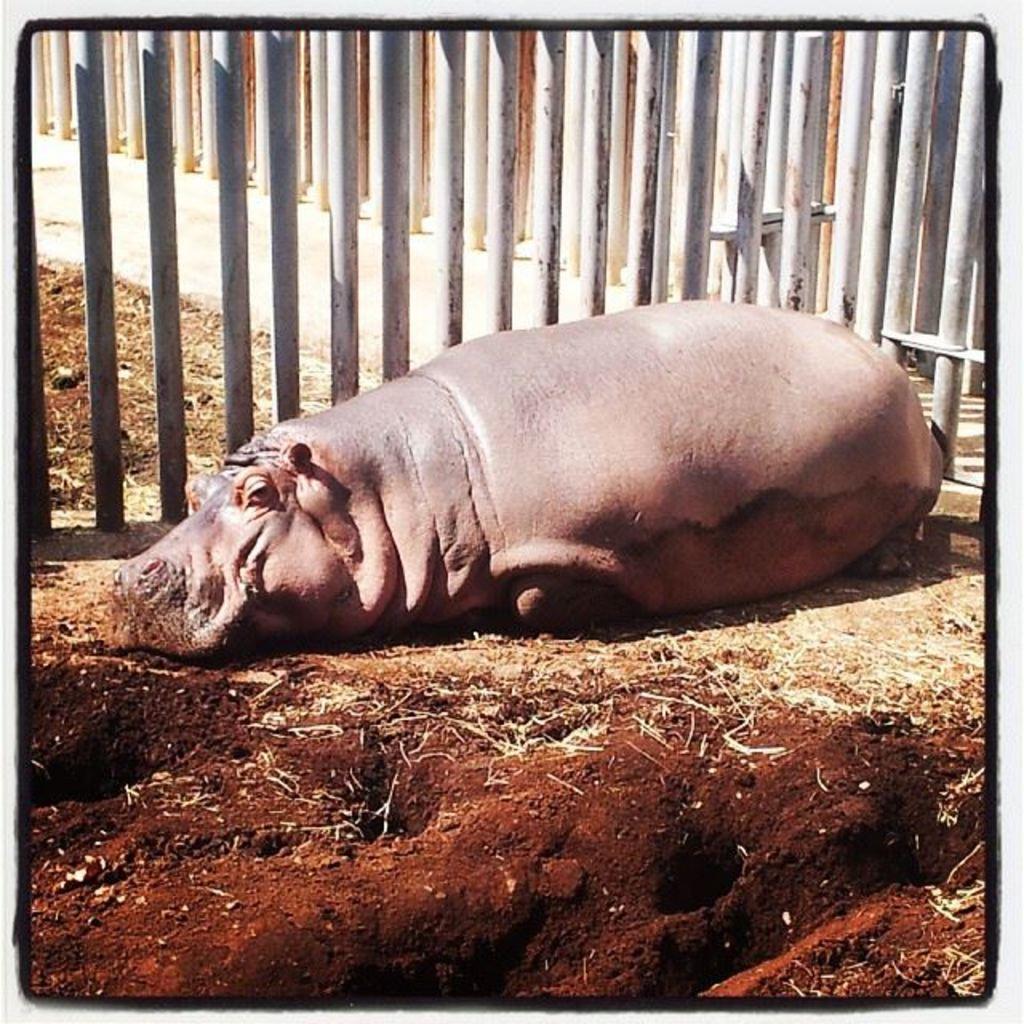Please provide a concise description of this image. In this image we can see hippopotamus which is resting on the ground behind fencing. 